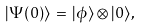Convert formula to latex. <formula><loc_0><loc_0><loc_500><loc_500>| \Psi ( 0 ) \rangle \, = \, | \phi \rangle \otimes | 0 \rangle \, ,</formula> 